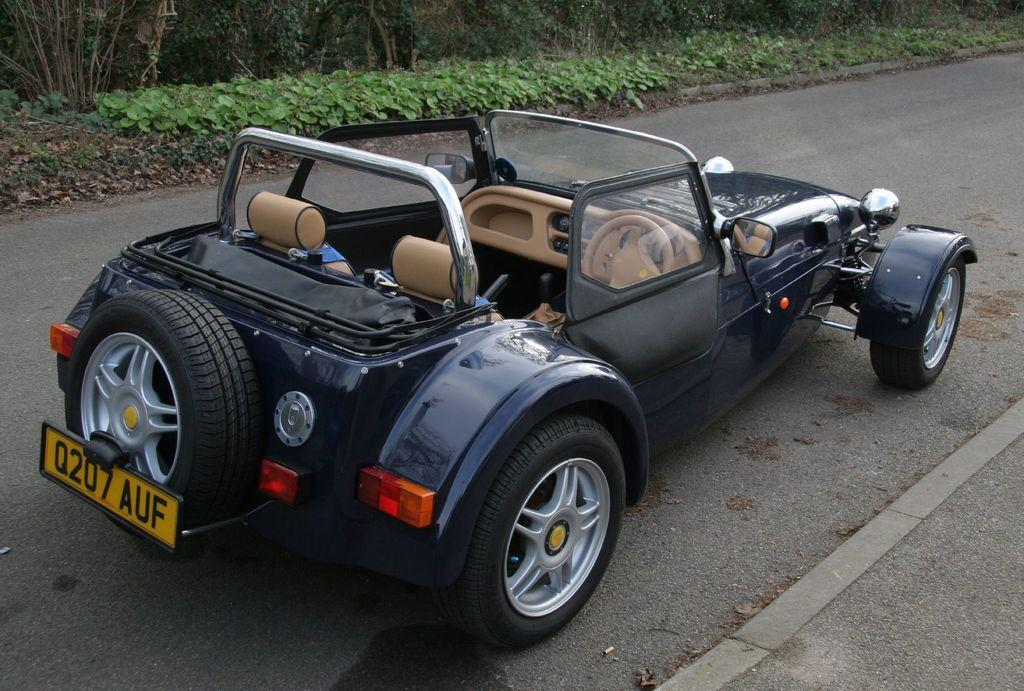What is the main subject of the image? There is a vehicle in the image. Where is the vehicle located? The vehicle is on the road. What can be seen in the background of the image? Trees and plants are visible in the image. What type of humor can be seen in the image? There is no humor present in the image; it features a vehicle on the road with trees and plants in the background. Can you tell me how many snakes are visible in the image? There are no snakes present in the image. 